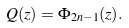Convert formula to latex. <formula><loc_0><loc_0><loc_500><loc_500>Q ( z ) = \Phi _ { 2 n - 1 } ( z ) .</formula> 